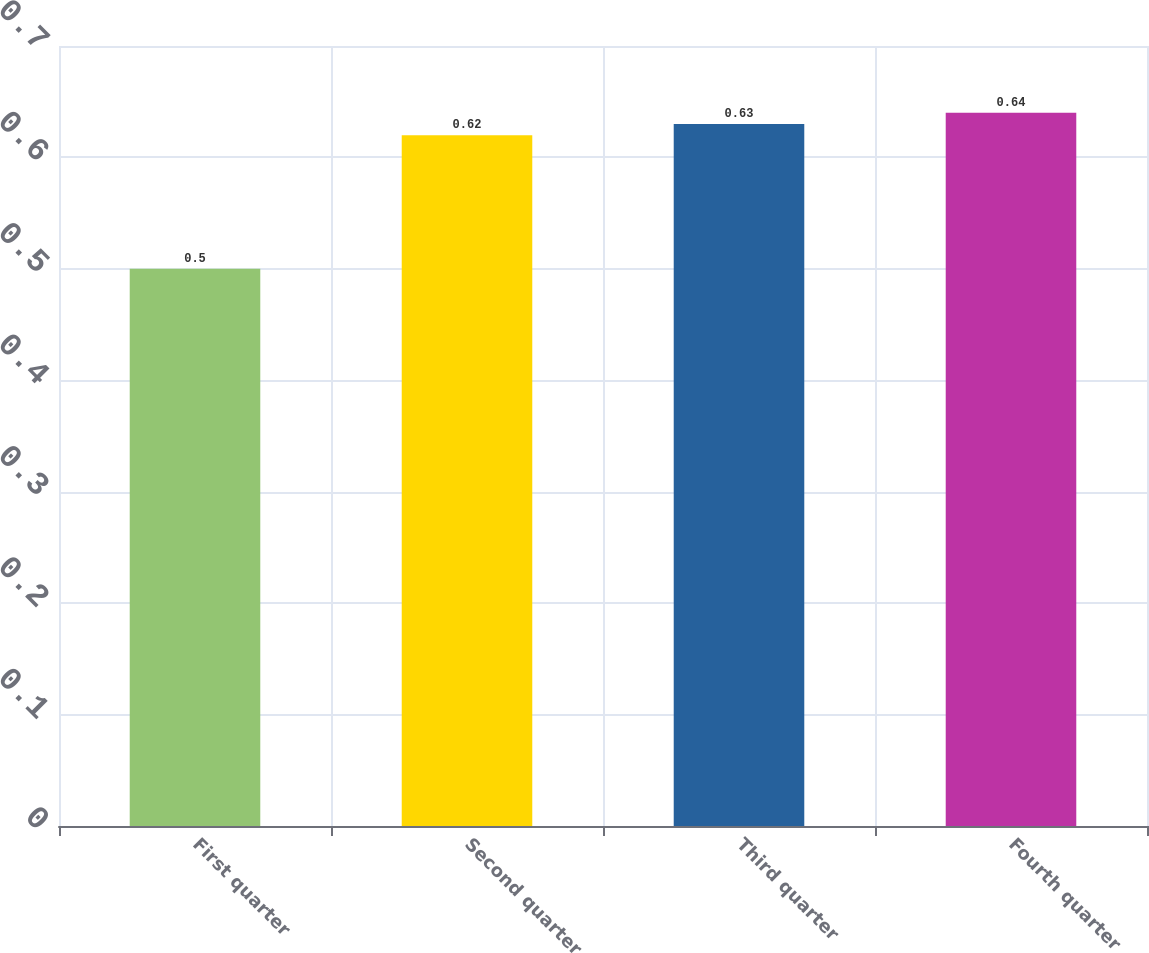<chart> <loc_0><loc_0><loc_500><loc_500><bar_chart><fcel>First quarter<fcel>Second quarter<fcel>Third quarter<fcel>Fourth quarter<nl><fcel>0.5<fcel>0.62<fcel>0.63<fcel>0.64<nl></chart> 